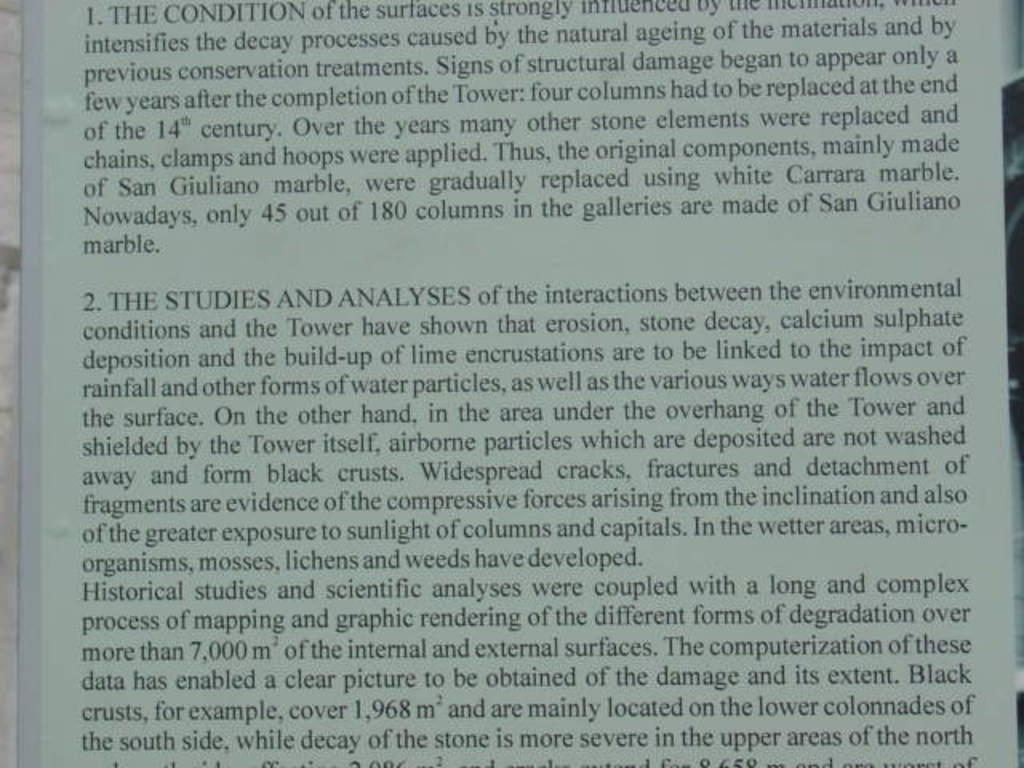<image>
Share a concise interpretation of the image provided. The article is about studies of interactions between a building and environmental conditions. 